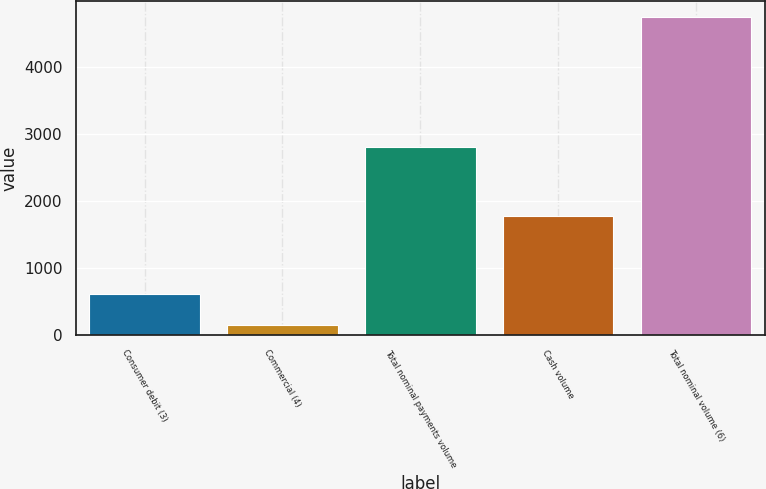<chart> <loc_0><loc_0><loc_500><loc_500><bar_chart><fcel>Consumer debit (3)<fcel>Commercial (4)<fcel>Total nominal payments volume<fcel>Cash volume<fcel>Total nominal volume (6)<nl><fcel>607.2<fcel>147<fcel>2800<fcel>1774<fcel>4749<nl></chart> 